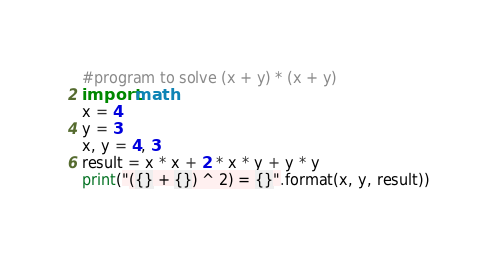Convert code to text. <code><loc_0><loc_0><loc_500><loc_500><_Python_>#program to solve (x + y) * (x + y)
import math
x = 4
y = 3
x, y = 4, 3
result = x * x + 2 * x * y + y * y
print("({} + {}) ^ 2) = {}".format(x, y, result))
</code> 